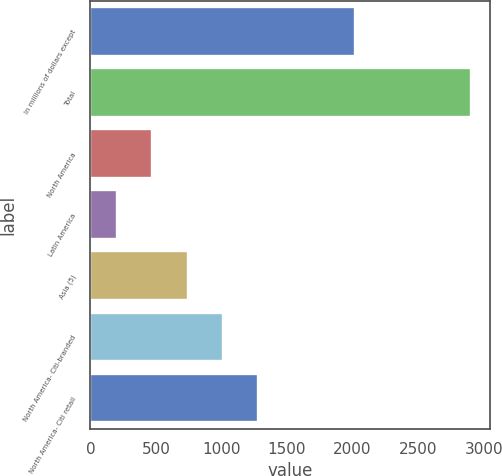Convert chart. <chart><loc_0><loc_0><loc_500><loc_500><bar_chart><fcel>In millions of dollars except<fcel>Total<fcel>North America<fcel>Latin America<fcel>Asia (5)<fcel>North America- Citi-branded<fcel>North America- Citi retail<nl><fcel>2018<fcel>2902<fcel>471.1<fcel>201<fcel>741.2<fcel>1011.3<fcel>1281.4<nl></chart> 